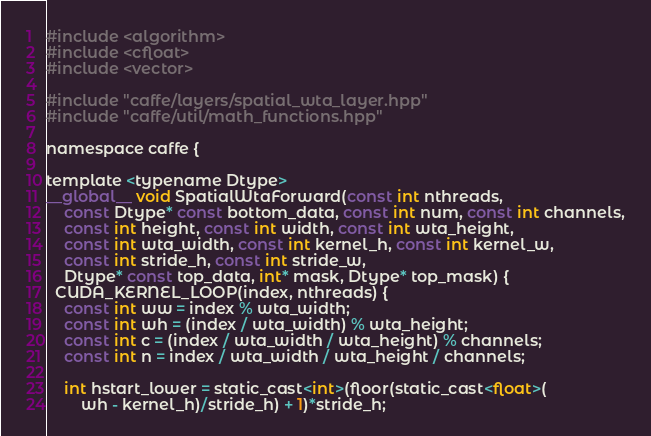<code> <loc_0><loc_0><loc_500><loc_500><_Cuda_>#include <algorithm>
#include <cfloat>
#include <vector>

#include "caffe/layers/spatial_wta_layer.hpp"
#include "caffe/util/math_functions.hpp"

namespace caffe {

template <typename Dtype>
__global__ void SpatialWtaForward(const int nthreads,
    const Dtype* const bottom_data, const int num, const int channels,
    const int height, const int width, const int wta_height,
    const int wta_width, const int kernel_h, const int kernel_w,
    const int stride_h, const int stride_w,
    Dtype* const top_data, int* mask, Dtype* top_mask) {
  CUDA_KERNEL_LOOP(index, nthreads) {
    const int ww = index % wta_width;
    const int wh = (index / wta_width) % wta_height;
    const int c = (index / wta_width / wta_height) % channels;
    const int n = index / wta_width / wta_height / channels;

    int hstart_lower = static_cast<int>(floor(static_cast<float>(
        wh - kernel_h)/stride_h) + 1)*stride_h;</code> 